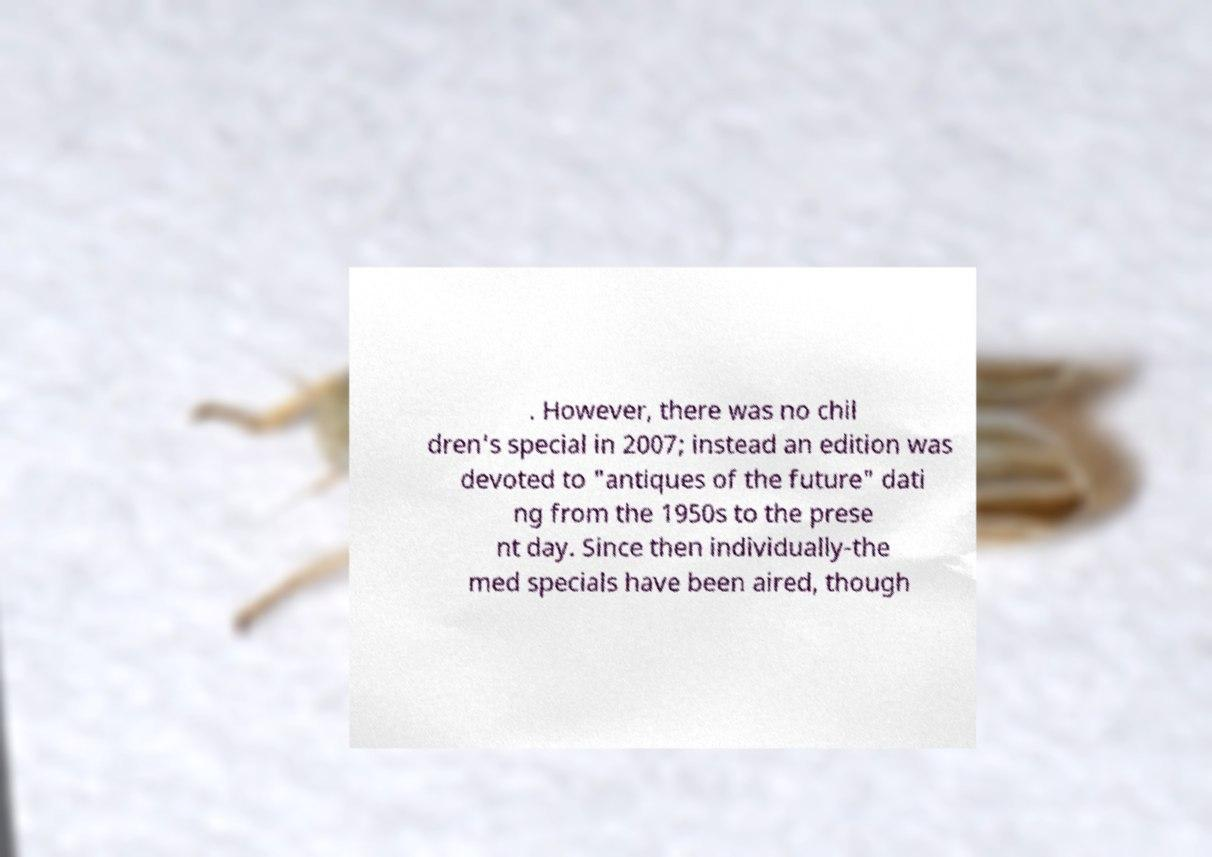Can you read and provide the text displayed in the image?This photo seems to have some interesting text. Can you extract and type it out for me? . However, there was no chil dren's special in 2007; instead an edition was devoted to "antiques of the future" dati ng from the 1950s to the prese nt day. Since then individually-the med specials have been aired, though 